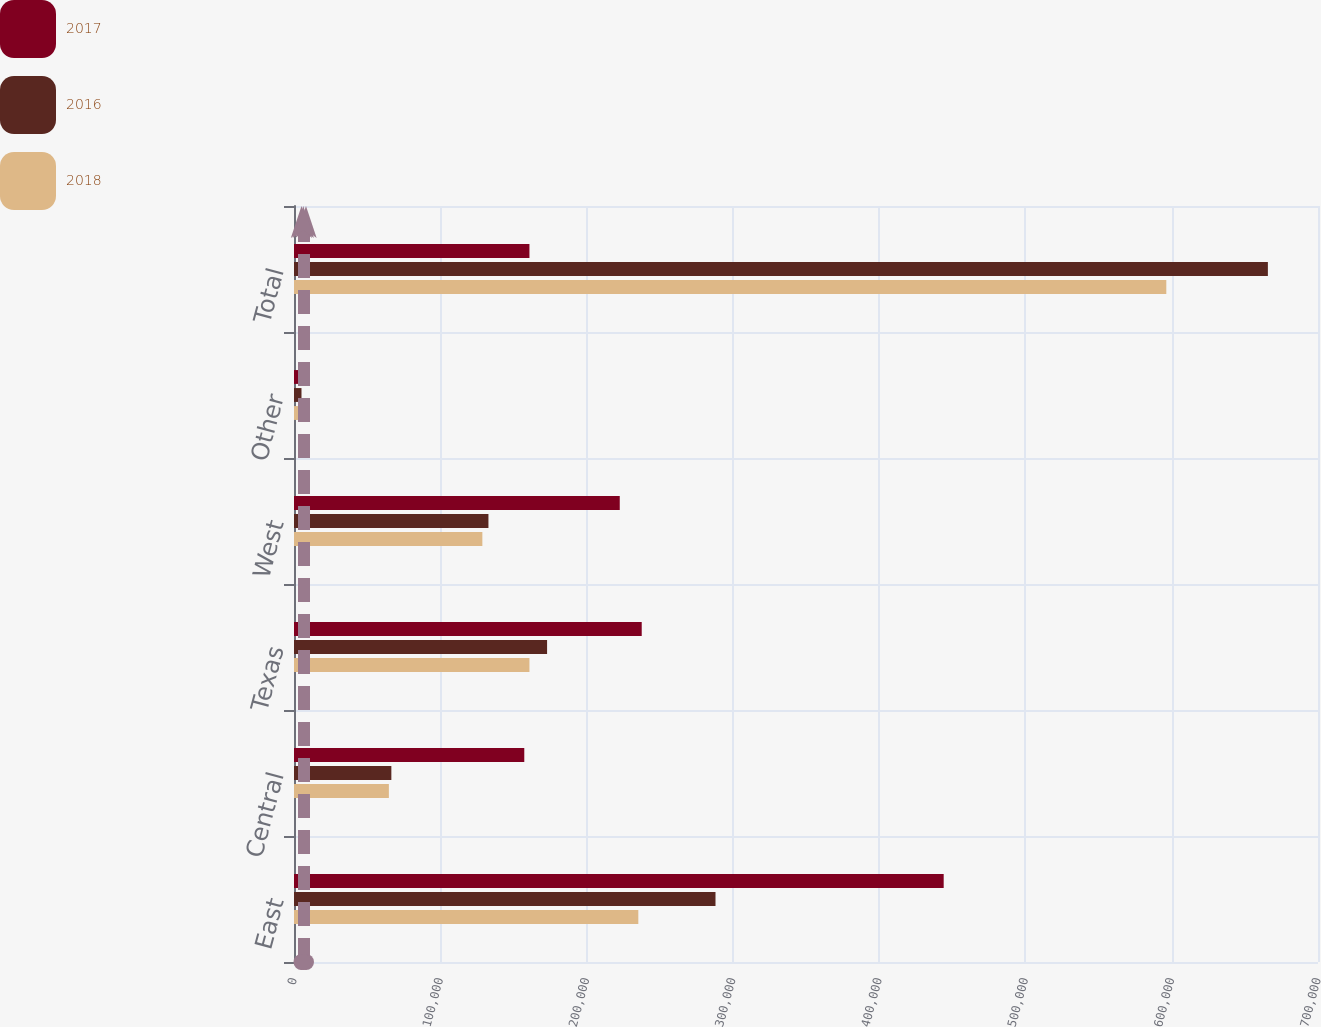Convert chart to OTSL. <chart><loc_0><loc_0><loc_500><loc_500><stacked_bar_chart><ecel><fcel>East<fcel>Central<fcel>Texas<fcel>West<fcel>Other<fcel>Total<nl><fcel>2017<fcel>444122<fcel>157420<fcel>237703<fcel>222684<fcel>8195<fcel>160950<nl><fcel>2016<fcel>288138<fcel>66554<fcel>173005<fcel>132920<fcel>5122<fcel>665739<nl><fcel>2018<fcel>235377<fcel>64856<fcel>160950<fcel>128761<fcel>6355<fcel>596299<nl></chart> 